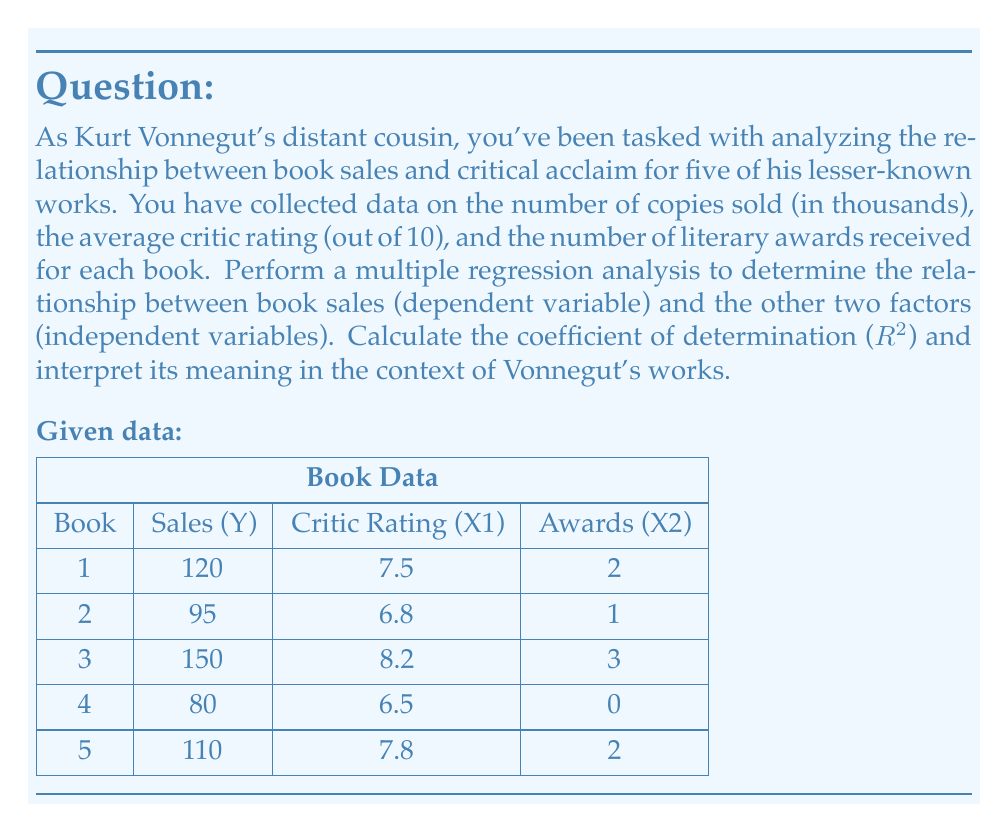What is the answer to this math problem? To perform a multiple regression analysis and calculate the coefficient of determination ($R^2$), we'll follow these steps:

1. Calculate the means of Y, X1, and X2:
   $\bar{Y} = 111$, $\bar{X_1} = 7.36$, $\bar{X_2} = 1.6$

2. Calculate the sums of squares and cross-products:
   $\sum (Y - \bar{Y})^2 = 2890$
   $\sum (X_1 - \bar{X_1})^2 = 2.054$
   $\sum (X_2 - \bar{X_2})^2 = 5.2$
   $\sum (Y - \bar{Y})(X_1 - \bar{X_1}) = 74.3$
   $\sum (Y - \bar{Y})(X_2 - \bar{X_2}) = 115$
   $\sum (X_1 - \bar{X_1})(X_2 - \bar{X_2}) = 2.78$

3. Set up the normal equations:
   $$\begin{cases}
   2.054b_1 + 2.78b_2 = 74.3 \\
   2.78b_1 + 5.2b_2 = 115
   \end{cases}$$

4. Solve the normal equations:
   $b_1 = 28.47$
   $b_2 = 13.91$

5. Calculate $b_0$:
   $b_0 = \bar{Y} - b_1\bar{X_1} - b_2\bar{X_2} = -97.56$

6. The regression equation is:
   $\hat{Y} = -97.56 + 28.47X_1 + 13.91X_2$

7. Calculate the total sum of squares (SST) and the regression sum of squares (SSR):
   $SST = \sum (Y - \bar{Y})^2 = 2890$
   $SSR = b_1 \sum (Y - \bar{Y})(X_1 - \bar{X_1}) + b_2 \sum (Y - \bar{Y})(X_2 - \bar{X_2}) = 2815.72$

8. Calculate $R^2$:
   $R^2 = \frac{SSR}{SST} = \frac{2815.72}{2890} = 0.9743$

Interpretation: The coefficient of determination ($R^2$) is 0.9743, which means that approximately 97.43% of the variation in book sales can be explained by the critic ratings and the number of literary awards received. This suggests a very strong relationship between these factors and the sales of Vonnegut's lesser-known works.
Answer: $R^2 = 0.9743$ or 97.43%

This indicates that 97.43% of the variation in book sales for Kurt Vonnegut's lesser-known works can be explained by the critic ratings and the number of literary awards received. 